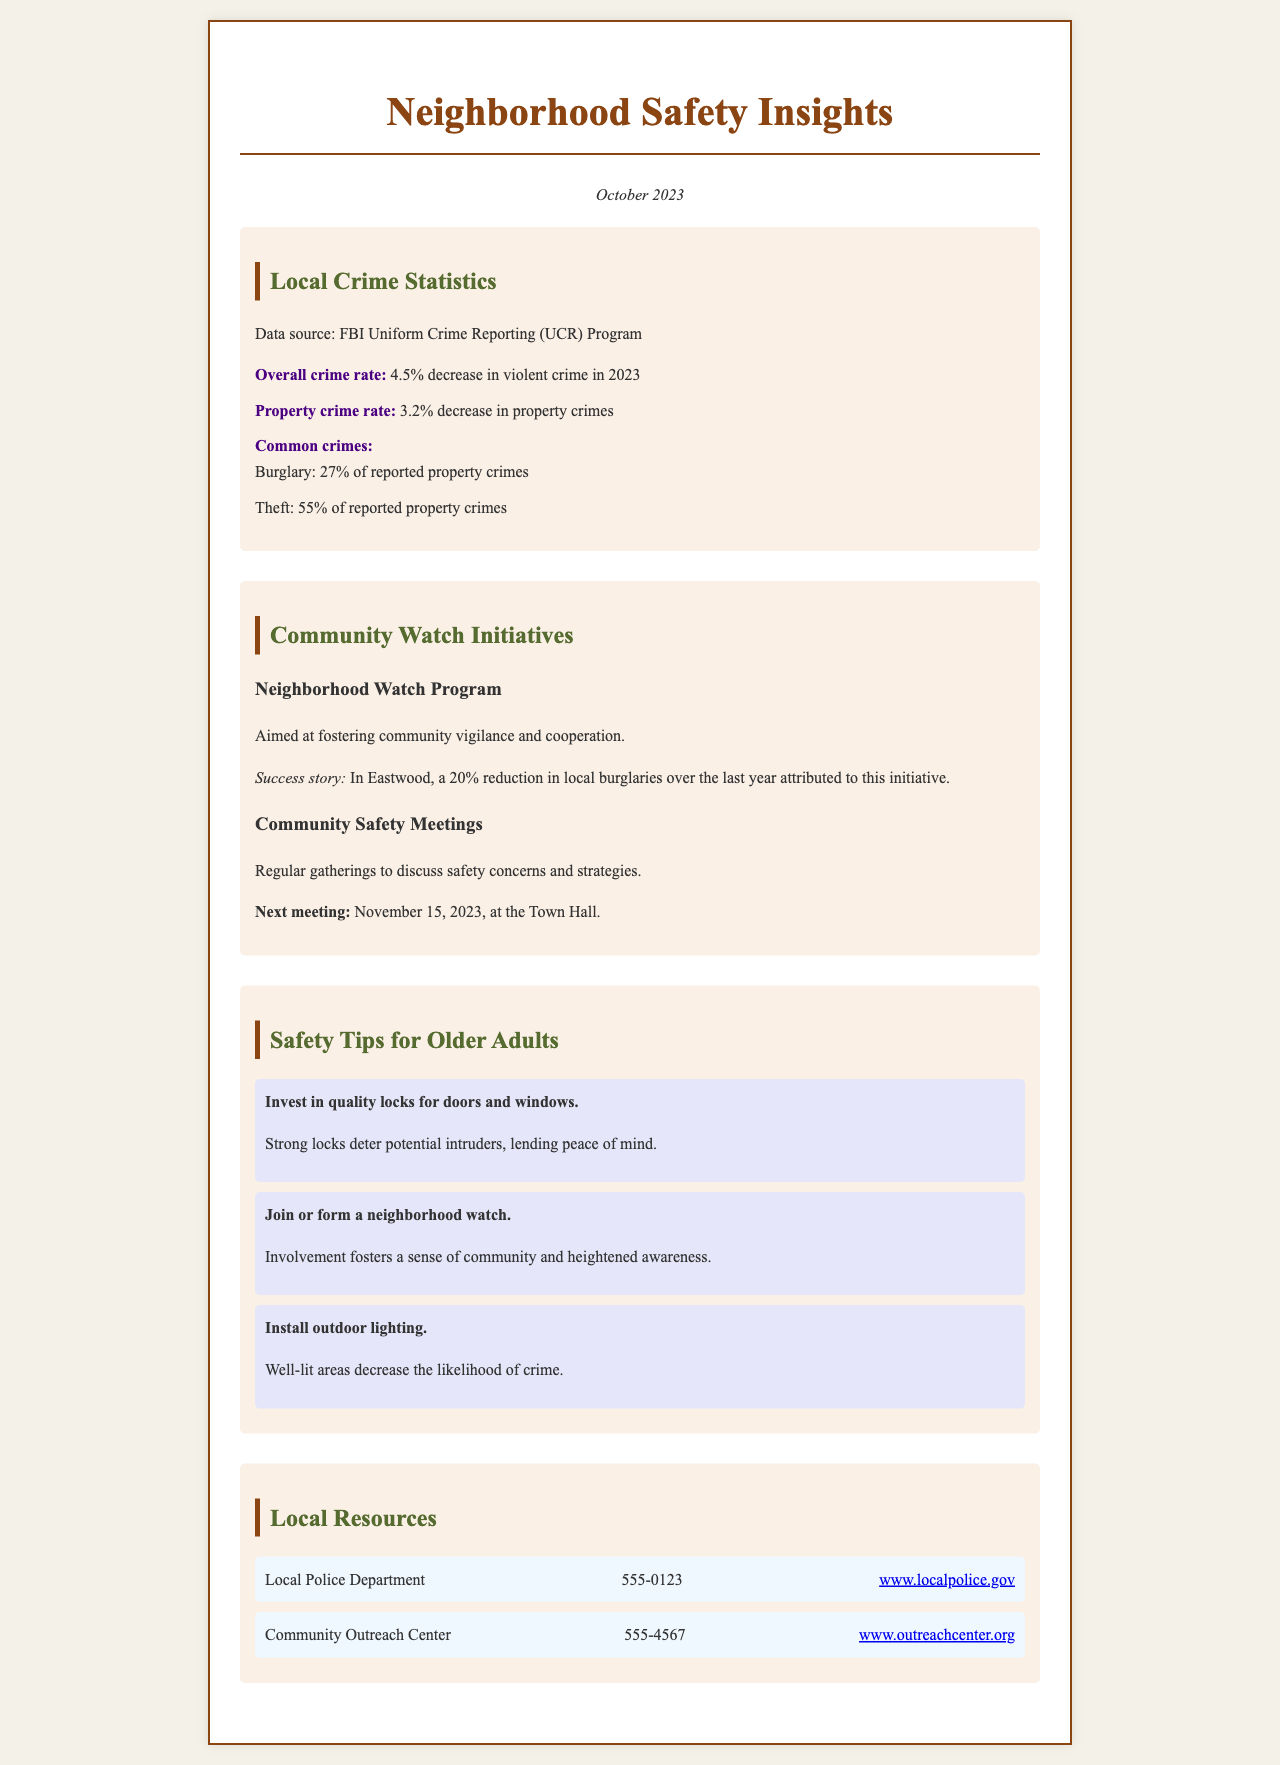What is the date of the newsletter? The date of the newsletter is mentioned at the top of the document.
Answer: October 2023 What is the percentage decrease in violent crime? The decrease in violent crime is specified in the local crime statistics section.
Answer: 4.5% What is the common type of property crime reported? The document lists types of property crimes in the statistics section.
Answer: Burglary What is the success story location for neighborhood watch? The location of the success story is indicated in the community watch initiatives section.
Answer: Eastwood When is the next community safety meeting? The date of the next meeting is provided in the community safety meetings section.
Answer: November 15, 2023 What is one key safety tip for older adults? The section on safety tips provides several recommendations for older adults.
Answer: Invest in quality locks for doors and windows What is the phone number for the local police department? The contact information for the local police department is listed in the local resources section.
Answer: 555-0123 How much did burglaries decrease in Eastwood due to the initiative? The decrease in burglaries due to the neighborhood watch is mentioned in the success story.
Answer: 20% What initiative is aimed at fostering community vigilance? The document mentions an initiative specifically designed for community vigilance.
Answer: Neighborhood Watch Program 